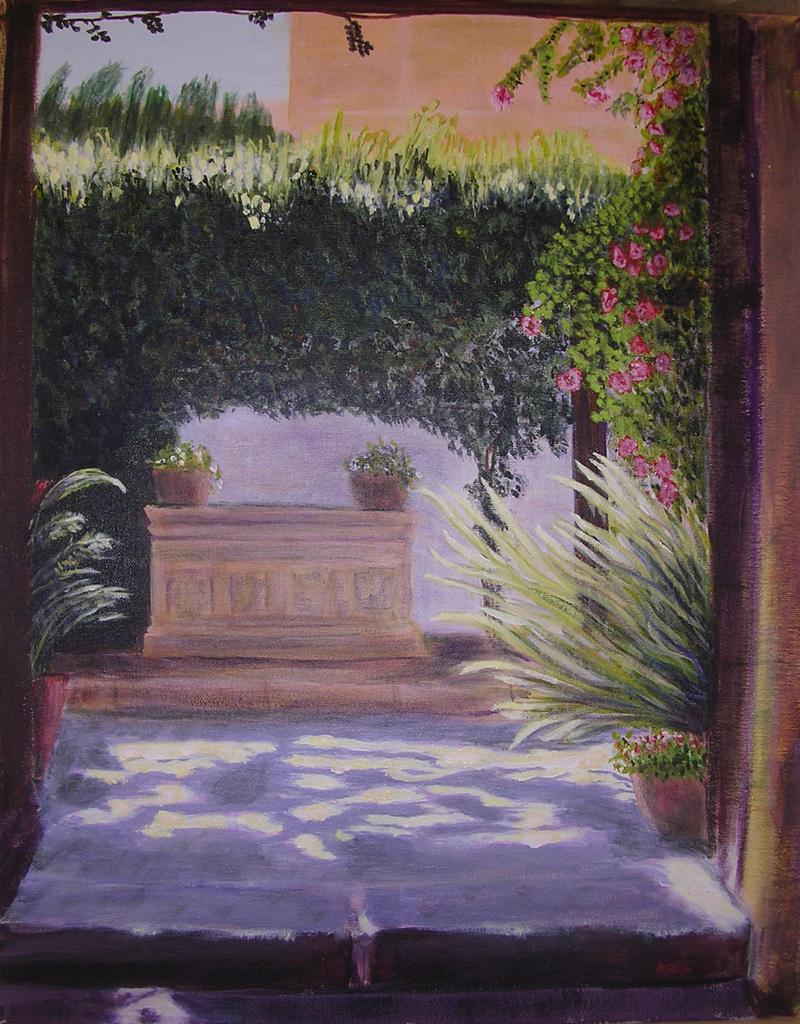What is the main subject of the image? There is a painting in the image. What elements are included in the painting? The painting contains trees, flowers, flower pots, and grass. Can you see any birds in the painting? There are no birds mentioned or visible in the painting; it primarily features trees, flowers, flower pots, and grass. 